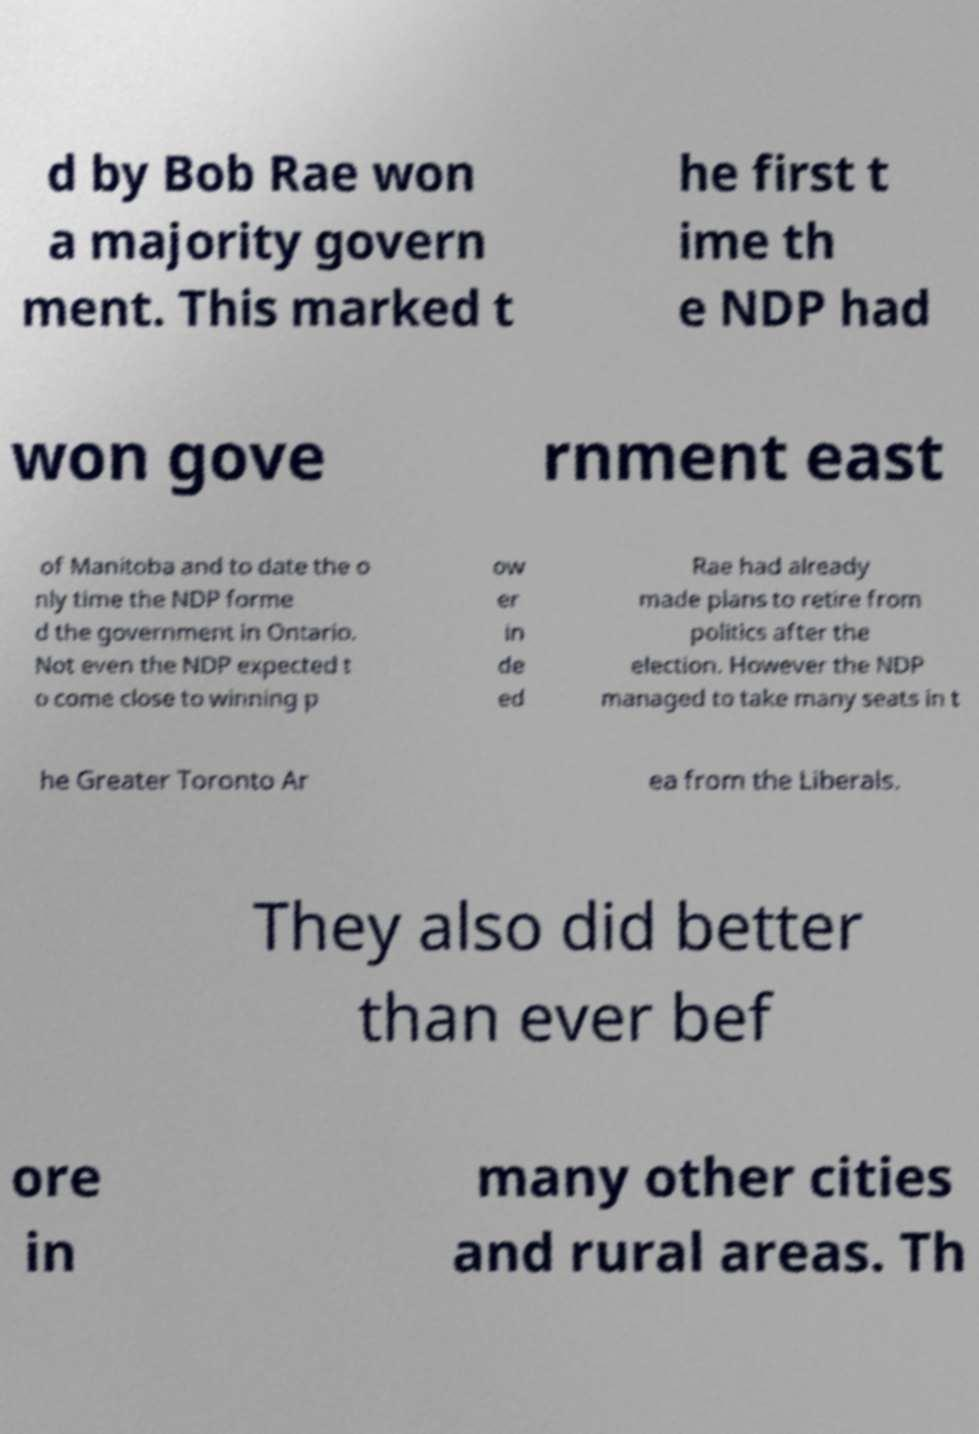I need the written content from this picture converted into text. Can you do that? d by Bob Rae won a majority govern ment. This marked t he first t ime th e NDP had won gove rnment east of Manitoba and to date the o nly time the NDP forme d the government in Ontario. Not even the NDP expected t o come close to winning p ow er in de ed Rae had already made plans to retire from politics after the election. However the NDP managed to take many seats in t he Greater Toronto Ar ea from the Liberals. They also did better than ever bef ore in many other cities and rural areas. Th 